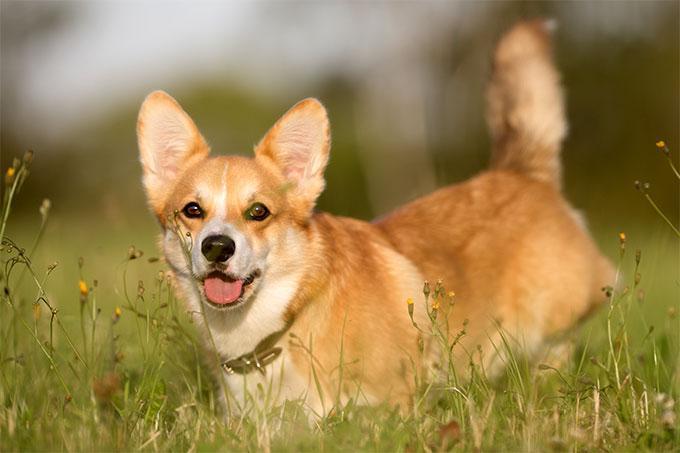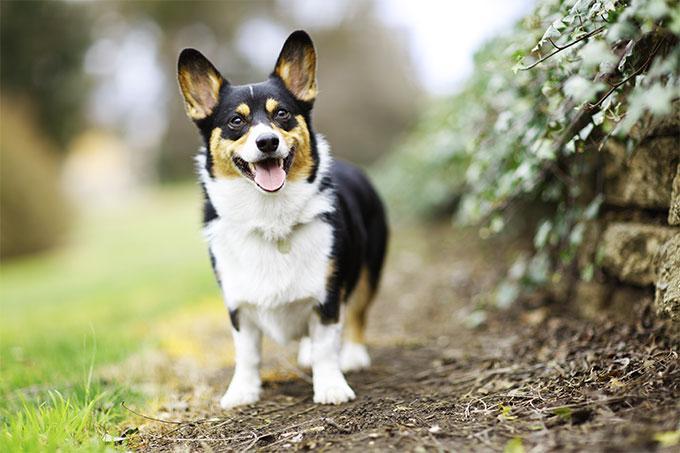The first image is the image on the left, the second image is the image on the right. For the images displayed, is the sentence "the dog in the image on the right is in side profile" factually correct? Answer yes or no. No. The first image is the image on the left, the second image is the image on the right. Assess this claim about the two images: "The dogs in the images are in profile, with one body turned to the right and the other to the left.". Correct or not? Answer yes or no. No. The first image is the image on the left, the second image is the image on the right. Examine the images to the left and right. Is the description "In one image, the dog is not on green grass." accurate? Answer yes or no. Yes. The first image is the image on the left, the second image is the image on the right. For the images displayed, is the sentence "All dogs in these images have the same basic pose and fur coloration." factually correct? Answer yes or no. No. The first image is the image on the left, the second image is the image on the right. For the images displayed, is the sentence "A dog in one image has a partial black coat and is looking up with its mouth open." factually correct? Answer yes or no. Yes. The first image is the image on the left, the second image is the image on the right. Evaluate the accuracy of this statement regarding the images: "At least one dog has it's head facing toward the left side of the image.". Is it true? Answer yes or no. No. 